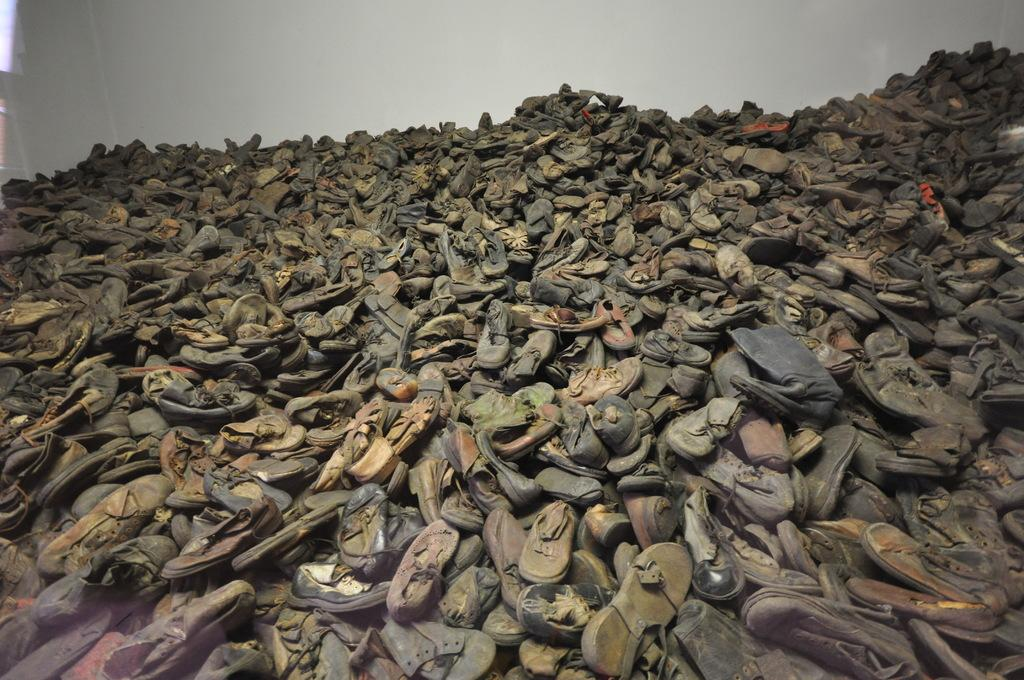What is the main subject of the image? There is a group of shoes in the image. What can be seen in the background of the image? There is a wall visible in the background of the image. Are there any other objects present in the background of the image? Yes, there are objects present in the background of the image. What type of magic is being performed with the box in the image? There is no box or magic present in the image; it features a group of shoes and a background with a wall and other objects. 